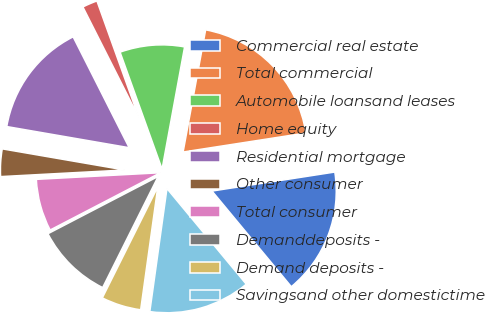<chart> <loc_0><loc_0><loc_500><loc_500><pie_chart><fcel>Commercial real estate<fcel>Total commercial<fcel>Automobile loansand leases<fcel>Home equity<fcel>Residential mortgage<fcel>Other consumer<fcel>Total consumer<fcel>Demanddeposits -<fcel>Demand deposits -<fcel>Savingsand other domestictime<nl><fcel>16.43%<fcel>19.65%<fcel>8.39%<fcel>1.96%<fcel>14.83%<fcel>3.57%<fcel>6.78%<fcel>10.0%<fcel>5.17%<fcel>13.22%<nl></chart> 